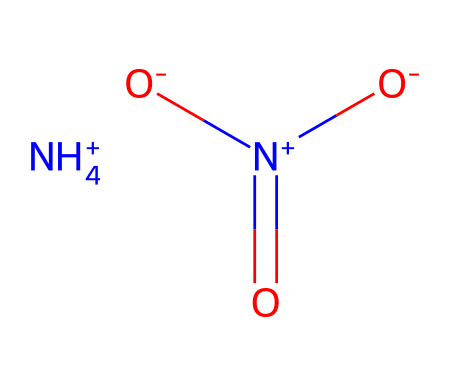What is the chemical name of this compound? The SMILES representation indicates the presence of ammonium and nitrate ions. The combination of these ions is known as ammonium nitrate.
Answer: ammonium nitrate How many different elements are present in this structure? The SMILES shows nitrogen (N), hydrogen (H), and oxygen (O), indicating three different elements.
Answer: three What is the total number of hydrogen atoms in this molecule? The ammonium ion (NH4+) contributes 4 hydrogen atoms, so the total number of hydrogen atoms is 4.
Answer: four Which part of the molecule acts as an oxidizer? The nitrate ion portion ([N+](=O)([O-])[O-]) provides the definition of an oxidizer due to its nitrogen in the +5 oxidation state and three bonded oxygens.
Answer: nitrate ion Is this compound ionic? The presence of positively charged ammonium ion and negatively charged nitrate ion indicates that the compound is formed through ionic bonds, confirming its ionic nature.
Answer: ionic What is the oxidation state of nitrogen in the nitrate ion? In the nitrate ion, the nitrogen has a formal oxidation state of +5 based on its connections to three oxygen atoms, each typically in -2 state.
Answer: +5 What kind of reaction is ammonium nitrate typically involved in when used as an oxidizer? Ammonium nitrate participates in exothermic redox reactions, often involving a fuel source to produce heat and gases.
Answer: redox reaction 